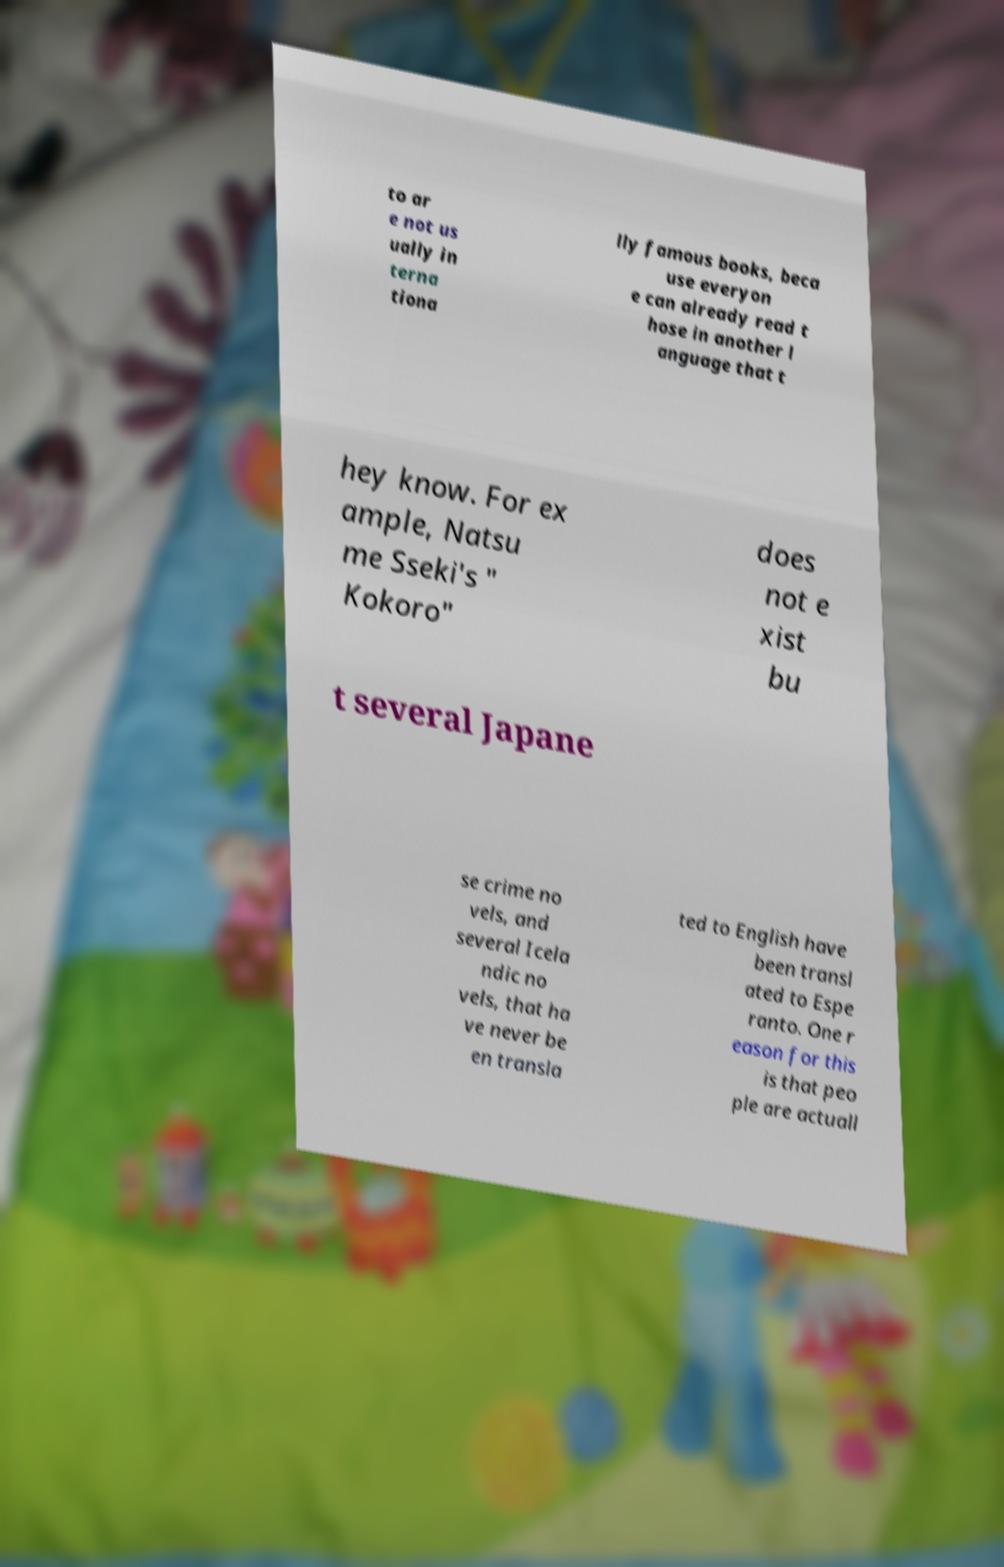There's text embedded in this image that I need extracted. Can you transcribe it verbatim? to ar e not us ually in terna tiona lly famous books, beca use everyon e can already read t hose in another l anguage that t hey know. For ex ample, Natsu me Sseki's " Kokoro" does not e xist bu t several Japane se crime no vels, and several Icela ndic no vels, that ha ve never be en transla ted to English have been transl ated to Espe ranto. One r eason for this is that peo ple are actuall 